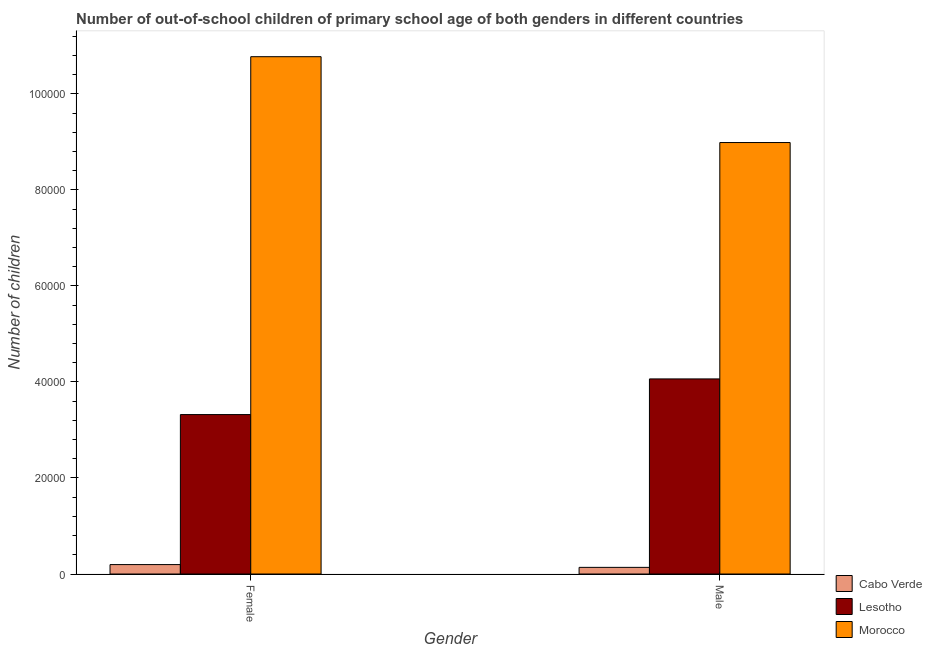How many different coloured bars are there?
Give a very brief answer. 3. Are the number of bars per tick equal to the number of legend labels?
Your answer should be very brief. Yes. How many bars are there on the 1st tick from the left?
Make the answer very short. 3. What is the label of the 2nd group of bars from the left?
Give a very brief answer. Male. What is the number of female out-of-school students in Cabo Verde?
Make the answer very short. 1962. Across all countries, what is the maximum number of male out-of-school students?
Your response must be concise. 8.99e+04. Across all countries, what is the minimum number of female out-of-school students?
Make the answer very short. 1962. In which country was the number of female out-of-school students maximum?
Your response must be concise. Morocco. In which country was the number of female out-of-school students minimum?
Give a very brief answer. Cabo Verde. What is the total number of male out-of-school students in the graph?
Make the answer very short. 1.32e+05. What is the difference between the number of male out-of-school students in Lesotho and that in Morocco?
Your answer should be very brief. -4.92e+04. What is the difference between the number of female out-of-school students in Lesotho and the number of male out-of-school students in Cabo Verde?
Make the answer very short. 3.18e+04. What is the average number of female out-of-school students per country?
Provide a succinct answer. 4.76e+04. What is the difference between the number of female out-of-school students and number of male out-of-school students in Lesotho?
Your answer should be compact. -7426. In how many countries, is the number of male out-of-school students greater than 80000 ?
Provide a succinct answer. 1. What is the ratio of the number of female out-of-school students in Lesotho to that in Cabo Verde?
Your response must be concise. 16.92. What does the 3rd bar from the left in Female represents?
Make the answer very short. Morocco. What does the 1st bar from the right in Male represents?
Ensure brevity in your answer.  Morocco. How many bars are there?
Offer a very short reply. 6. Are all the bars in the graph horizontal?
Ensure brevity in your answer.  No. How many countries are there in the graph?
Your answer should be very brief. 3. Does the graph contain any zero values?
Offer a very short reply. No. Does the graph contain grids?
Your answer should be compact. No. Where does the legend appear in the graph?
Your answer should be very brief. Bottom right. How are the legend labels stacked?
Give a very brief answer. Vertical. What is the title of the graph?
Give a very brief answer. Number of out-of-school children of primary school age of both genders in different countries. Does "Canada" appear as one of the legend labels in the graph?
Offer a terse response. No. What is the label or title of the Y-axis?
Offer a terse response. Number of children. What is the Number of children of Cabo Verde in Female?
Offer a terse response. 1962. What is the Number of children of Lesotho in Female?
Provide a succinct answer. 3.32e+04. What is the Number of children of Morocco in Female?
Your response must be concise. 1.08e+05. What is the Number of children of Cabo Verde in Male?
Offer a very short reply. 1383. What is the Number of children in Lesotho in Male?
Your answer should be compact. 4.06e+04. What is the Number of children in Morocco in Male?
Your answer should be compact. 8.99e+04. Across all Gender, what is the maximum Number of children in Cabo Verde?
Your answer should be very brief. 1962. Across all Gender, what is the maximum Number of children in Lesotho?
Provide a short and direct response. 4.06e+04. Across all Gender, what is the maximum Number of children of Morocco?
Provide a short and direct response. 1.08e+05. Across all Gender, what is the minimum Number of children of Cabo Verde?
Your answer should be compact. 1383. Across all Gender, what is the minimum Number of children in Lesotho?
Provide a succinct answer. 3.32e+04. Across all Gender, what is the minimum Number of children of Morocco?
Offer a terse response. 8.99e+04. What is the total Number of children of Cabo Verde in the graph?
Ensure brevity in your answer.  3345. What is the total Number of children in Lesotho in the graph?
Provide a short and direct response. 7.38e+04. What is the total Number of children in Morocco in the graph?
Your answer should be very brief. 1.98e+05. What is the difference between the Number of children of Cabo Verde in Female and that in Male?
Make the answer very short. 579. What is the difference between the Number of children in Lesotho in Female and that in Male?
Give a very brief answer. -7426. What is the difference between the Number of children of Morocco in Female and that in Male?
Your answer should be very brief. 1.79e+04. What is the difference between the Number of children in Cabo Verde in Female and the Number of children in Lesotho in Male?
Your response must be concise. -3.87e+04. What is the difference between the Number of children of Cabo Verde in Female and the Number of children of Morocco in Male?
Your answer should be very brief. -8.79e+04. What is the difference between the Number of children of Lesotho in Female and the Number of children of Morocco in Male?
Provide a short and direct response. -5.67e+04. What is the average Number of children of Cabo Verde per Gender?
Provide a succinct answer. 1672.5. What is the average Number of children in Lesotho per Gender?
Offer a very short reply. 3.69e+04. What is the average Number of children of Morocco per Gender?
Your response must be concise. 9.88e+04. What is the difference between the Number of children in Cabo Verde and Number of children in Lesotho in Female?
Your response must be concise. -3.12e+04. What is the difference between the Number of children in Cabo Verde and Number of children in Morocco in Female?
Provide a short and direct response. -1.06e+05. What is the difference between the Number of children of Lesotho and Number of children of Morocco in Female?
Ensure brevity in your answer.  -7.45e+04. What is the difference between the Number of children of Cabo Verde and Number of children of Lesotho in Male?
Ensure brevity in your answer.  -3.92e+04. What is the difference between the Number of children of Cabo Verde and Number of children of Morocco in Male?
Your response must be concise. -8.85e+04. What is the difference between the Number of children of Lesotho and Number of children of Morocco in Male?
Keep it short and to the point. -4.92e+04. What is the ratio of the Number of children in Cabo Verde in Female to that in Male?
Make the answer very short. 1.42. What is the ratio of the Number of children in Lesotho in Female to that in Male?
Provide a short and direct response. 0.82. What is the ratio of the Number of children of Morocco in Female to that in Male?
Ensure brevity in your answer.  1.2. What is the difference between the highest and the second highest Number of children in Cabo Verde?
Give a very brief answer. 579. What is the difference between the highest and the second highest Number of children in Lesotho?
Offer a terse response. 7426. What is the difference between the highest and the second highest Number of children in Morocco?
Your answer should be very brief. 1.79e+04. What is the difference between the highest and the lowest Number of children in Cabo Verde?
Provide a short and direct response. 579. What is the difference between the highest and the lowest Number of children of Lesotho?
Provide a succinct answer. 7426. What is the difference between the highest and the lowest Number of children in Morocco?
Provide a short and direct response. 1.79e+04. 